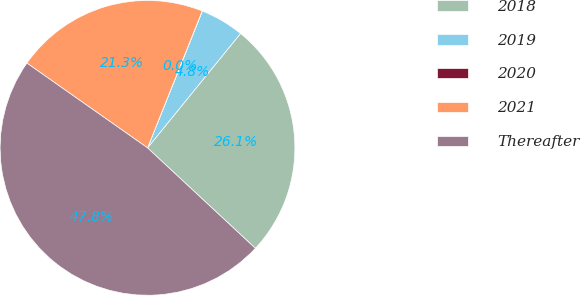<chart> <loc_0><loc_0><loc_500><loc_500><pie_chart><fcel>2018<fcel>2019<fcel>2020<fcel>2021<fcel>Thereafter<nl><fcel>26.07%<fcel>4.8%<fcel>0.02%<fcel>21.3%<fcel>47.82%<nl></chart> 